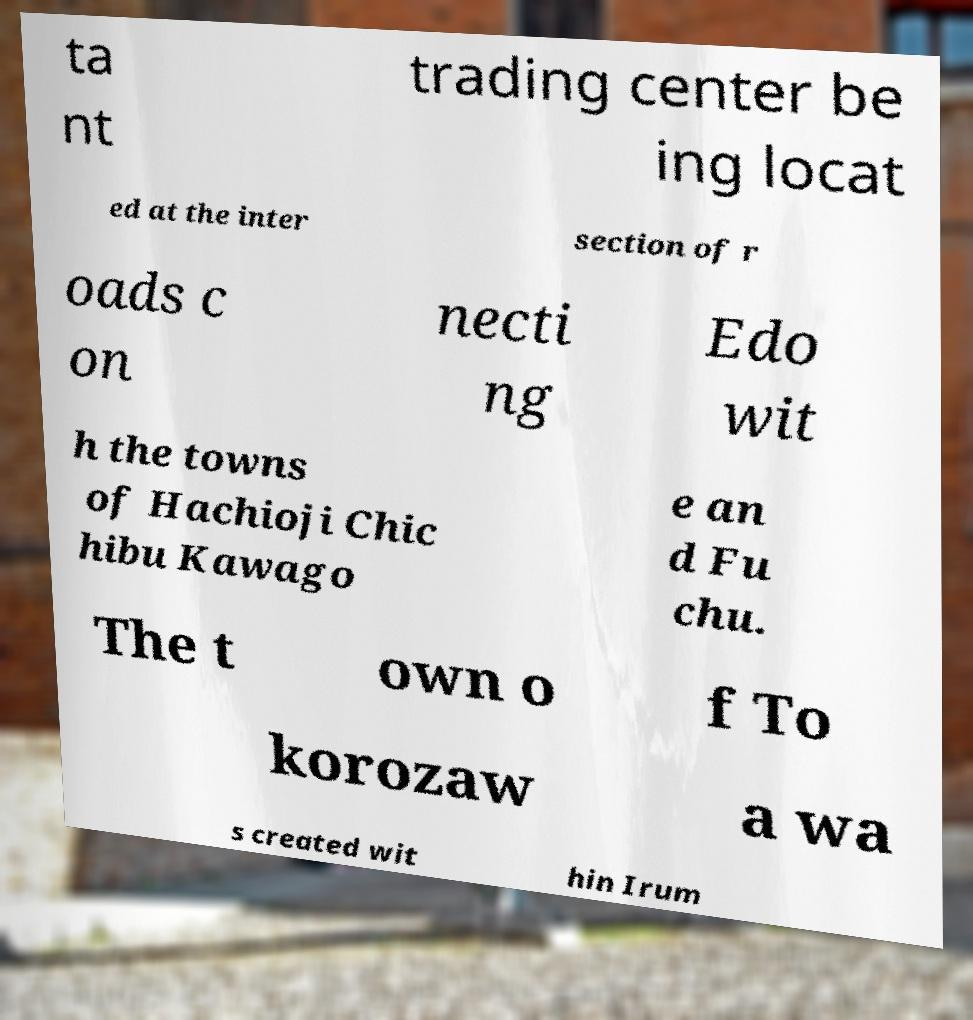There's text embedded in this image that I need extracted. Can you transcribe it verbatim? ta nt trading center be ing locat ed at the inter section of r oads c on necti ng Edo wit h the towns of Hachioji Chic hibu Kawago e an d Fu chu. The t own o f To korozaw a wa s created wit hin Irum 